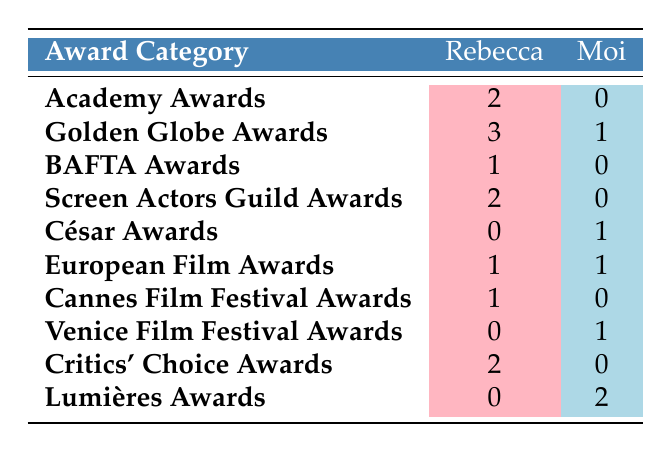What is the total number of Academy Awards won by Rebecca? The table shows that Rebecca has won 2 Academy Awards.
Answer: 2 How many Golden Globe Awards does the French actor have? The table indicates that the French actor has won 1 Golden Globe Award.
Answer: 1 Which actor has more BAFTA Awards? Rebecca has won 1 BAFTA Award, while the French actor has 0, making Rebecca the one with more.
Answer: Rebecca What is the difference in the number of Screen Actors Guild Awards won by Rebecca and the French actor? Rebecca has won 2, and the French actor has won 0. The difference is 2 - 0 = 2.
Answer: 2 Did the French actor win any Cannes Film Festival Awards? According to the table, the French actor has won 0 Cannes Film Festival Awards.
Answer: No How many awards has each actor won in total across all categories listed? Summing up the awards for Rebecca: 2 + 3 + 1 + 2 + 0 + 1 + 1 + 0 + 2 + 0 = 12. For the French actor: 0 + 1 + 0 + 0 + 1 + 1 + 0 + 1 + 0 + 2 = 6.
Answer: Rebecca: 12, French actor: 6 Is it true that Rebecca has more Critics' Choice Awards than the French actor? Yes, Rebecca has won 2 Critics' Choice Awards while the French actor has won 0.
Answer: Yes Which award category shows the largest difference in wins between Rebecca and the French actor? Comparing the awards, the largest difference is in the Golden Globe Awards where Rebecca has 3 and the French actor has 1, giving a difference of 3 - 1 = 2.
Answer: Golden Globe Awards Did the French actor win more awards than Rebecca in the Lumières Awards category? No, the French actor has 2 Lumières Awards while Rebecca has 0. The French actor has more in this category.
Answer: Yes 